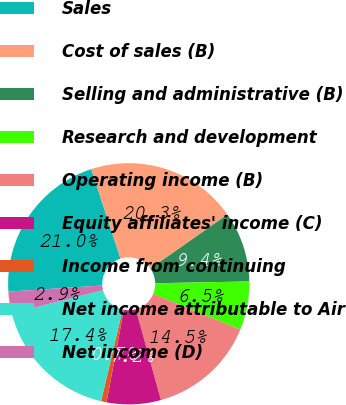Convert chart. <chart><loc_0><loc_0><loc_500><loc_500><pie_chart><fcel>Sales<fcel>Cost of sales (B)<fcel>Selling and administrative (B)<fcel>Research and development<fcel>Operating income (B)<fcel>Equity affiliates' income (C)<fcel>Income from continuing<fcel>Net income attributable to Air<fcel>Net income (D)<nl><fcel>21.01%<fcel>20.29%<fcel>9.42%<fcel>6.52%<fcel>14.49%<fcel>7.25%<fcel>0.73%<fcel>17.39%<fcel>2.9%<nl></chart> 